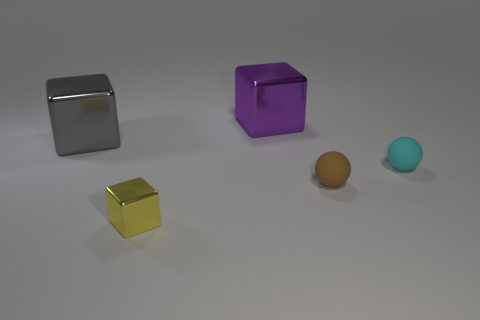Add 1 tiny brown matte balls. How many objects exist? 6 Subtract all cubes. How many objects are left? 2 Add 5 large blue things. How many large blue things exist? 5 Subtract 1 yellow cubes. How many objects are left? 4 Subtract all purple metallic cubes. Subtract all tiny yellow shiny objects. How many objects are left? 3 Add 5 purple shiny objects. How many purple shiny objects are left? 6 